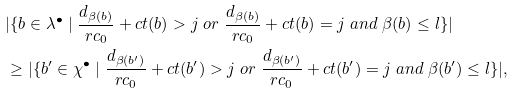Convert formula to latex. <formula><loc_0><loc_0><loc_500><loc_500>& | \{ b \in \lambda ^ { \bullet } \ | \ \frac { d _ { \beta ( b ) } } { r c _ { 0 } } + c t ( b ) > j \ o r \ \frac { d _ { \beta ( b ) } } { r c _ { 0 } } + c t ( b ) = j \ a n d \ \beta ( b ) \leq l \} | \\ & \geq | \{ b ^ { \prime } \in \chi ^ { \bullet } \ | \ \frac { d _ { \beta ( b ^ { \prime } ) } } { r c _ { 0 } } + c t ( b ^ { \prime } ) > j \ o r \ \frac { d _ { \beta ( b ^ { \prime } ) } } { r c _ { 0 } } + c t ( b ^ { \prime } ) = j \ a n d \ \beta ( b ^ { \prime } ) \leq l \} | ,</formula> 